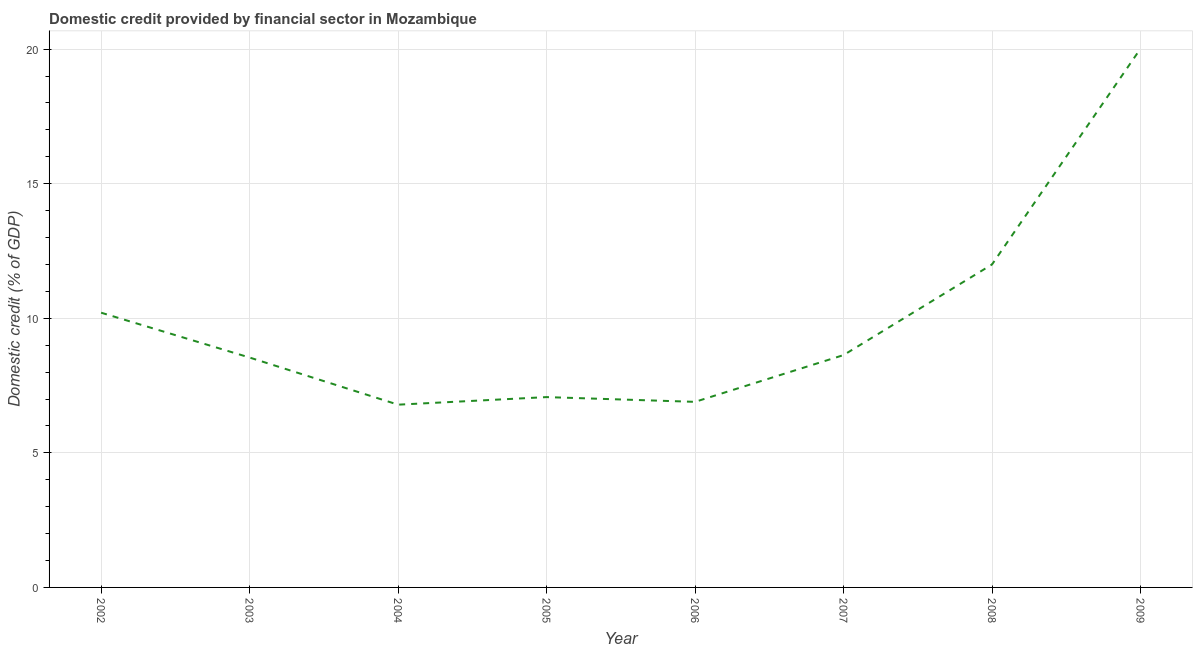What is the domestic credit provided by financial sector in 2004?
Your answer should be compact. 6.79. Across all years, what is the maximum domestic credit provided by financial sector?
Your answer should be very brief. 20.02. Across all years, what is the minimum domestic credit provided by financial sector?
Ensure brevity in your answer.  6.79. In which year was the domestic credit provided by financial sector minimum?
Offer a very short reply. 2004. What is the sum of the domestic credit provided by financial sector?
Keep it short and to the point. 80.16. What is the difference between the domestic credit provided by financial sector in 2004 and 2009?
Make the answer very short. -13.23. What is the average domestic credit provided by financial sector per year?
Make the answer very short. 10.02. What is the median domestic credit provided by financial sector?
Ensure brevity in your answer.  8.59. In how many years, is the domestic credit provided by financial sector greater than 12 %?
Offer a very short reply. 2. What is the ratio of the domestic credit provided by financial sector in 2005 to that in 2009?
Offer a very short reply. 0.35. Is the domestic credit provided by financial sector in 2004 less than that in 2009?
Your answer should be compact. Yes. Is the difference between the domestic credit provided by financial sector in 2005 and 2006 greater than the difference between any two years?
Make the answer very short. No. What is the difference between the highest and the second highest domestic credit provided by financial sector?
Offer a very short reply. 8.02. Is the sum of the domestic credit provided by financial sector in 2005 and 2008 greater than the maximum domestic credit provided by financial sector across all years?
Offer a terse response. No. What is the difference between the highest and the lowest domestic credit provided by financial sector?
Offer a terse response. 13.23. How many lines are there?
Offer a very short reply. 1. Are the values on the major ticks of Y-axis written in scientific E-notation?
Provide a short and direct response. No. Does the graph contain any zero values?
Provide a short and direct response. No. What is the title of the graph?
Your answer should be compact. Domestic credit provided by financial sector in Mozambique. What is the label or title of the X-axis?
Provide a short and direct response. Year. What is the label or title of the Y-axis?
Make the answer very short. Domestic credit (% of GDP). What is the Domestic credit (% of GDP) of 2002?
Provide a short and direct response. 10.21. What is the Domestic credit (% of GDP) in 2003?
Ensure brevity in your answer.  8.54. What is the Domestic credit (% of GDP) of 2004?
Your answer should be compact. 6.79. What is the Domestic credit (% of GDP) in 2005?
Your response must be concise. 7.07. What is the Domestic credit (% of GDP) in 2006?
Your answer should be very brief. 6.9. What is the Domestic credit (% of GDP) of 2007?
Provide a succinct answer. 8.63. What is the Domestic credit (% of GDP) in 2008?
Offer a very short reply. 12. What is the Domestic credit (% of GDP) in 2009?
Make the answer very short. 20.02. What is the difference between the Domestic credit (% of GDP) in 2002 and 2003?
Keep it short and to the point. 1.67. What is the difference between the Domestic credit (% of GDP) in 2002 and 2004?
Make the answer very short. 3.42. What is the difference between the Domestic credit (% of GDP) in 2002 and 2005?
Your response must be concise. 3.14. What is the difference between the Domestic credit (% of GDP) in 2002 and 2006?
Ensure brevity in your answer.  3.31. What is the difference between the Domestic credit (% of GDP) in 2002 and 2007?
Keep it short and to the point. 1.57. What is the difference between the Domestic credit (% of GDP) in 2002 and 2008?
Offer a terse response. -1.79. What is the difference between the Domestic credit (% of GDP) in 2002 and 2009?
Your answer should be very brief. -9.81. What is the difference between the Domestic credit (% of GDP) in 2003 and 2004?
Provide a short and direct response. 1.75. What is the difference between the Domestic credit (% of GDP) in 2003 and 2005?
Provide a succinct answer. 1.47. What is the difference between the Domestic credit (% of GDP) in 2003 and 2006?
Keep it short and to the point. 1.65. What is the difference between the Domestic credit (% of GDP) in 2003 and 2007?
Keep it short and to the point. -0.09. What is the difference between the Domestic credit (% of GDP) in 2003 and 2008?
Offer a terse response. -3.46. What is the difference between the Domestic credit (% of GDP) in 2003 and 2009?
Your answer should be compact. -11.48. What is the difference between the Domestic credit (% of GDP) in 2004 and 2005?
Offer a very short reply. -0.28. What is the difference between the Domestic credit (% of GDP) in 2004 and 2006?
Ensure brevity in your answer.  -0.1. What is the difference between the Domestic credit (% of GDP) in 2004 and 2007?
Your response must be concise. -1.84. What is the difference between the Domestic credit (% of GDP) in 2004 and 2008?
Offer a terse response. -5.21. What is the difference between the Domestic credit (% of GDP) in 2004 and 2009?
Make the answer very short. -13.23. What is the difference between the Domestic credit (% of GDP) in 2005 and 2006?
Offer a very short reply. 0.18. What is the difference between the Domestic credit (% of GDP) in 2005 and 2007?
Give a very brief answer. -1.56. What is the difference between the Domestic credit (% of GDP) in 2005 and 2008?
Your response must be concise. -4.93. What is the difference between the Domestic credit (% of GDP) in 2005 and 2009?
Offer a very short reply. -12.95. What is the difference between the Domestic credit (% of GDP) in 2006 and 2007?
Make the answer very short. -1.74. What is the difference between the Domestic credit (% of GDP) in 2006 and 2008?
Your response must be concise. -5.11. What is the difference between the Domestic credit (% of GDP) in 2006 and 2009?
Your answer should be compact. -13.12. What is the difference between the Domestic credit (% of GDP) in 2007 and 2008?
Give a very brief answer. -3.37. What is the difference between the Domestic credit (% of GDP) in 2007 and 2009?
Ensure brevity in your answer.  -11.39. What is the difference between the Domestic credit (% of GDP) in 2008 and 2009?
Provide a succinct answer. -8.02. What is the ratio of the Domestic credit (% of GDP) in 2002 to that in 2003?
Your response must be concise. 1.2. What is the ratio of the Domestic credit (% of GDP) in 2002 to that in 2004?
Give a very brief answer. 1.5. What is the ratio of the Domestic credit (% of GDP) in 2002 to that in 2005?
Provide a short and direct response. 1.44. What is the ratio of the Domestic credit (% of GDP) in 2002 to that in 2006?
Your response must be concise. 1.48. What is the ratio of the Domestic credit (% of GDP) in 2002 to that in 2007?
Your answer should be very brief. 1.18. What is the ratio of the Domestic credit (% of GDP) in 2002 to that in 2008?
Make the answer very short. 0.85. What is the ratio of the Domestic credit (% of GDP) in 2002 to that in 2009?
Provide a succinct answer. 0.51. What is the ratio of the Domestic credit (% of GDP) in 2003 to that in 2004?
Your response must be concise. 1.26. What is the ratio of the Domestic credit (% of GDP) in 2003 to that in 2005?
Offer a terse response. 1.21. What is the ratio of the Domestic credit (% of GDP) in 2003 to that in 2006?
Ensure brevity in your answer.  1.24. What is the ratio of the Domestic credit (% of GDP) in 2003 to that in 2007?
Provide a short and direct response. 0.99. What is the ratio of the Domestic credit (% of GDP) in 2003 to that in 2008?
Your response must be concise. 0.71. What is the ratio of the Domestic credit (% of GDP) in 2003 to that in 2009?
Provide a succinct answer. 0.43. What is the ratio of the Domestic credit (% of GDP) in 2004 to that in 2007?
Offer a very short reply. 0.79. What is the ratio of the Domestic credit (% of GDP) in 2004 to that in 2008?
Make the answer very short. 0.57. What is the ratio of the Domestic credit (% of GDP) in 2004 to that in 2009?
Offer a very short reply. 0.34. What is the ratio of the Domestic credit (% of GDP) in 2005 to that in 2007?
Provide a short and direct response. 0.82. What is the ratio of the Domestic credit (% of GDP) in 2005 to that in 2008?
Your answer should be compact. 0.59. What is the ratio of the Domestic credit (% of GDP) in 2005 to that in 2009?
Offer a terse response. 0.35. What is the ratio of the Domestic credit (% of GDP) in 2006 to that in 2007?
Your answer should be very brief. 0.8. What is the ratio of the Domestic credit (% of GDP) in 2006 to that in 2008?
Your answer should be compact. 0.57. What is the ratio of the Domestic credit (% of GDP) in 2006 to that in 2009?
Your answer should be very brief. 0.34. What is the ratio of the Domestic credit (% of GDP) in 2007 to that in 2008?
Provide a short and direct response. 0.72. What is the ratio of the Domestic credit (% of GDP) in 2007 to that in 2009?
Ensure brevity in your answer.  0.43. What is the ratio of the Domestic credit (% of GDP) in 2008 to that in 2009?
Offer a very short reply. 0.6. 